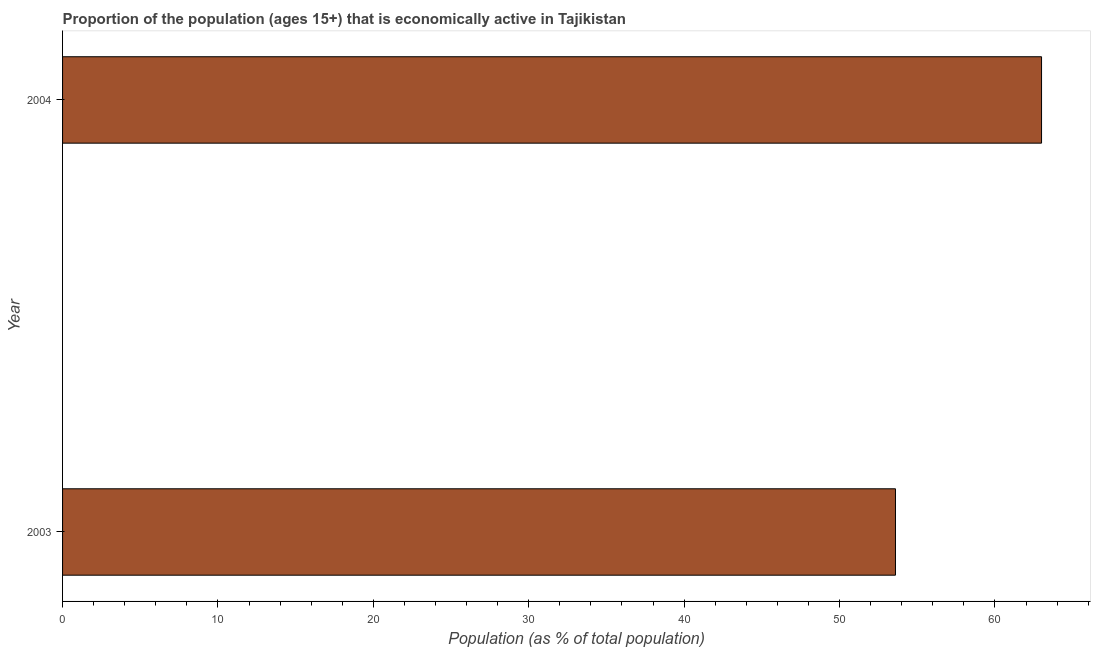Does the graph contain any zero values?
Offer a terse response. No. Does the graph contain grids?
Provide a short and direct response. No. What is the title of the graph?
Offer a terse response. Proportion of the population (ages 15+) that is economically active in Tajikistan. What is the label or title of the X-axis?
Your answer should be compact. Population (as % of total population). What is the percentage of economically active population in 2003?
Provide a succinct answer. 53.6. Across all years, what is the minimum percentage of economically active population?
Your answer should be compact. 53.6. In which year was the percentage of economically active population maximum?
Offer a very short reply. 2004. What is the sum of the percentage of economically active population?
Your answer should be very brief. 116.6. What is the difference between the percentage of economically active population in 2003 and 2004?
Your answer should be very brief. -9.4. What is the average percentage of economically active population per year?
Your answer should be compact. 58.3. What is the median percentage of economically active population?
Your response must be concise. 58.3. Do a majority of the years between 2003 and 2004 (inclusive) have percentage of economically active population greater than 58 %?
Your response must be concise. No. What is the ratio of the percentage of economically active population in 2003 to that in 2004?
Make the answer very short. 0.85. How many bars are there?
Offer a terse response. 2. How many years are there in the graph?
Ensure brevity in your answer.  2. What is the difference between two consecutive major ticks on the X-axis?
Keep it short and to the point. 10. What is the Population (as % of total population) of 2003?
Offer a very short reply. 53.6. What is the Population (as % of total population) in 2004?
Your answer should be compact. 63. What is the difference between the Population (as % of total population) in 2003 and 2004?
Your response must be concise. -9.4. What is the ratio of the Population (as % of total population) in 2003 to that in 2004?
Your answer should be very brief. 0.85. 